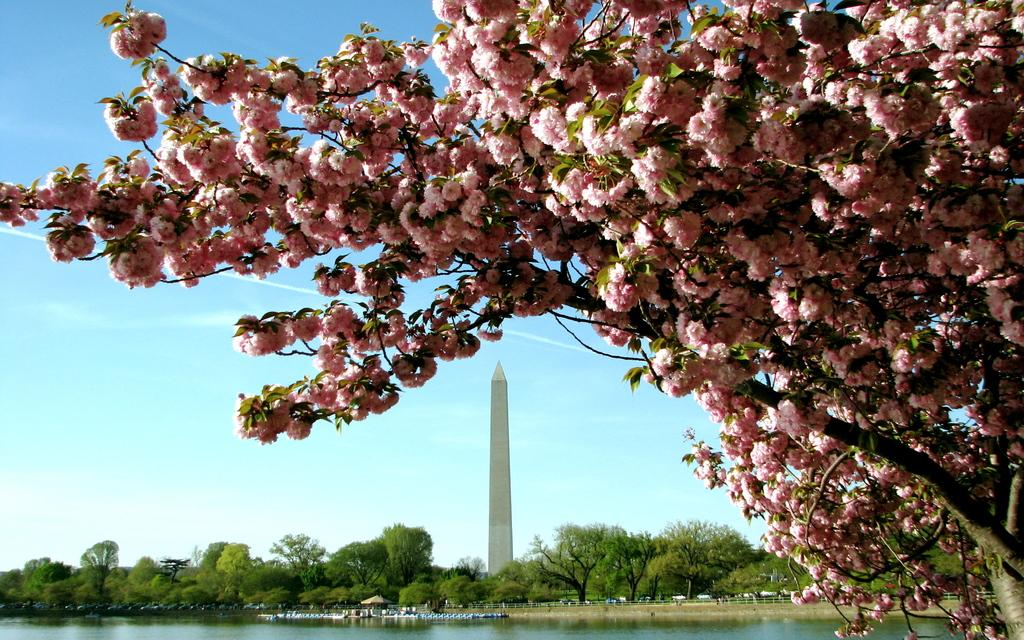What type of tree is present in the image? There is a tree with light pink flowers in the image. What structure can be seen in the image? There appears to be a tower in the image. What is happening with the water in the image? Water is flowing in the image. What other vegetation is present in the image? There are trees in the image. What type of box is being delivered by the news to the beginner in the image? There is no box, news, or beginner present in the image. 